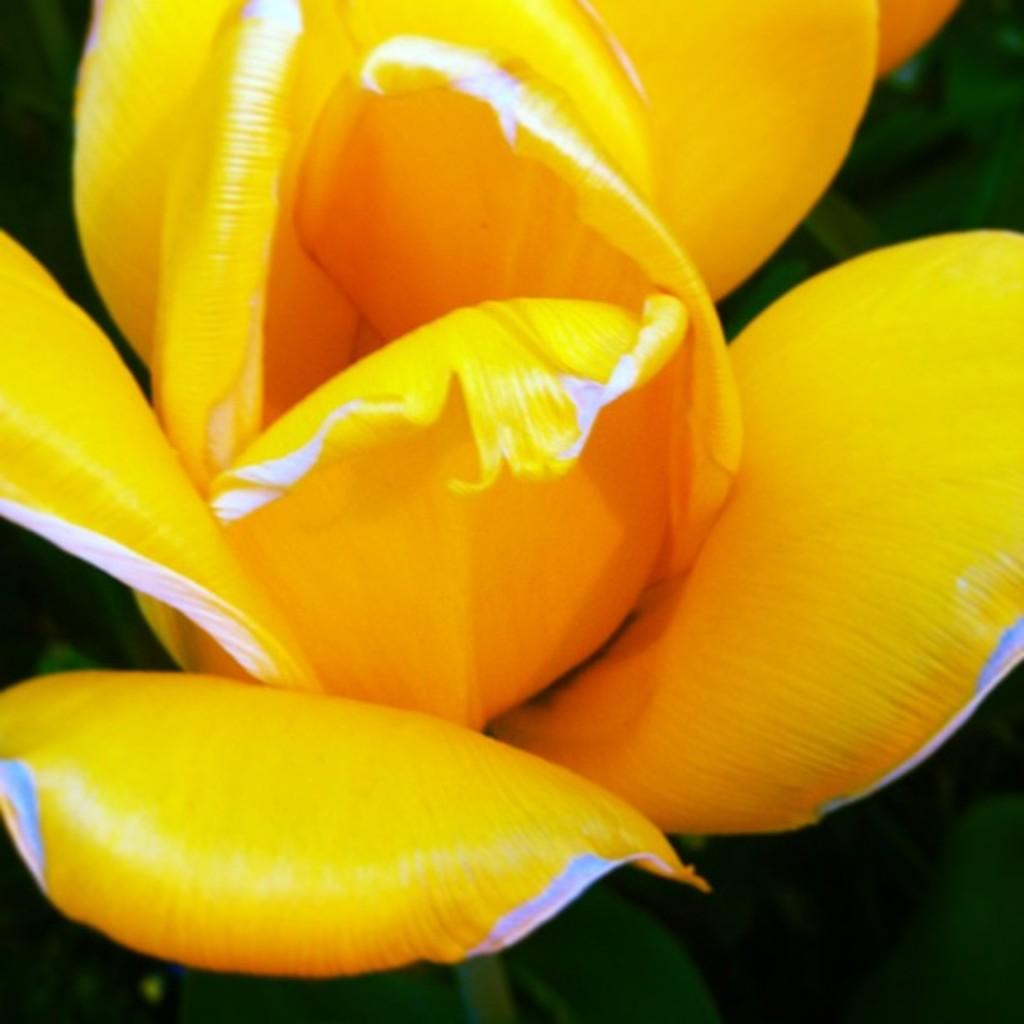What is the main subject of the image? There is a flower in the image. What color is the flower? The flower is yellow in color. What can be seen in the background of the image? There are green color things in the background of the image. What position does the governor hold in the image? There is no governor present in the image; it features a yellow flower and green color things in the background. How many basketballs are visible in the image? There are no basketballs present in the image. 